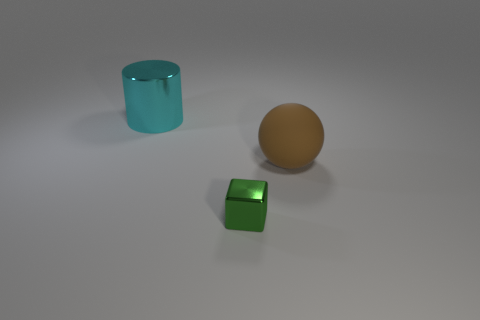Can you guess what time of day it is or what the lighting suggests about the setting? The diffuse and soft lighting in the image doesn't provide clear indicators of the time of day. It appears more like studio lighting used in photography or 3D renderings, designed to highlight the objects without creating harsh shadows, suggesting an indoor setting. 